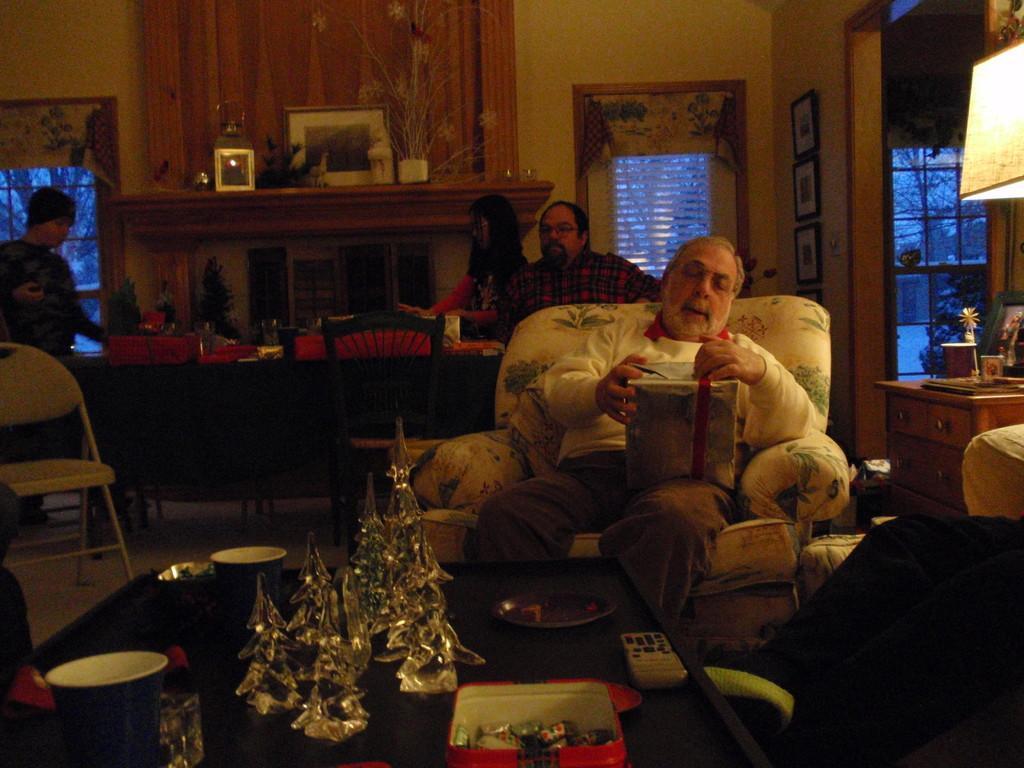Could you give a brief overview of what you see in this image? In this picture here we can see 5 people. At the center we have old man who is sitting and looking at gif. In front of him there is a table present. On the table we have tea cups, remote control, chocolates etc. Behind him we have large dining table. In the background we have wall, photo frames present. It seems like a house. 